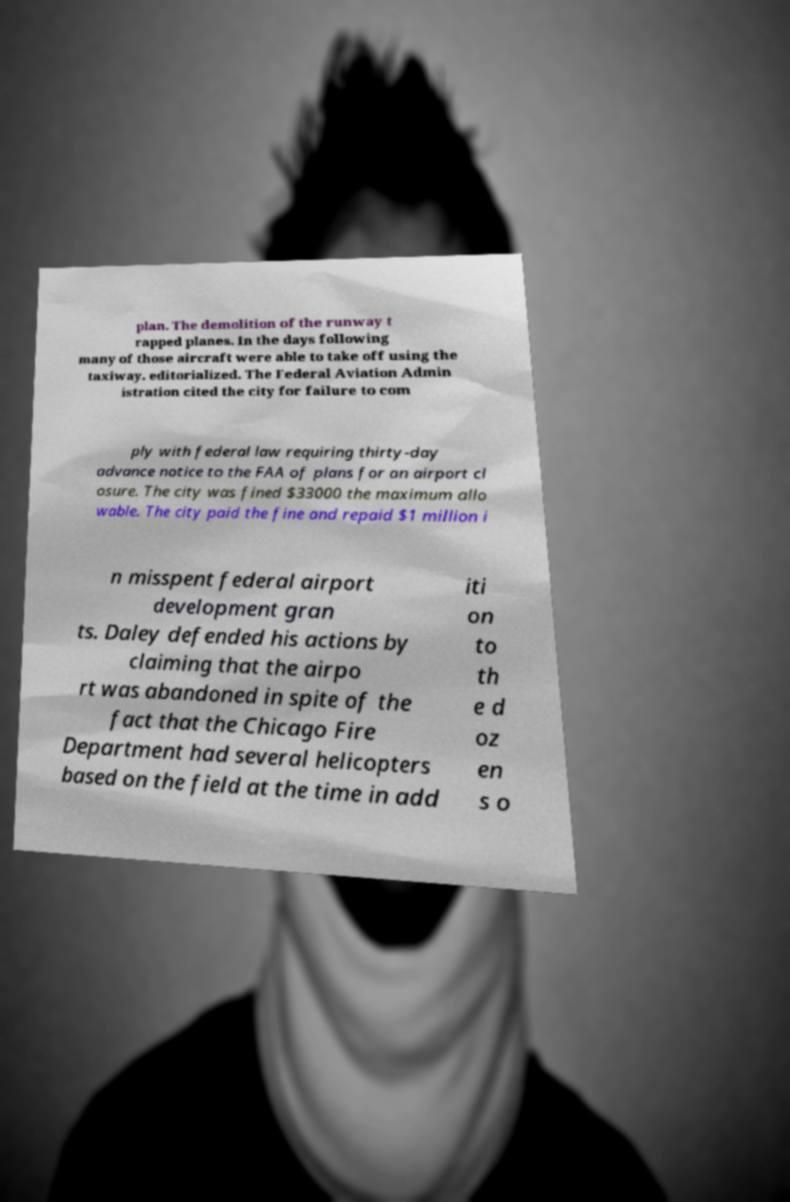Could you extract and type out the text from this image? plan. The demolition of the runway t rapped planes. In the days following many of those aircraft were able to take off using the taxiway. editorialized. The Federal Aviation Admin istration cited the city for failure to com ply with federal law requiring thirty-day advance notice to the FAA of plans for an airport cl osure. The city was fined $33000 the maximum allo wable. The city paid the fine and repaid $1 million i n misspent federal airport development gran ts. Daley defended his actions by claiming that the airpo rt was abandoned in spite of the fact that the Chicago Fire Department had several helicopters based on the field at the time in add iti on to th e d oz en s o 